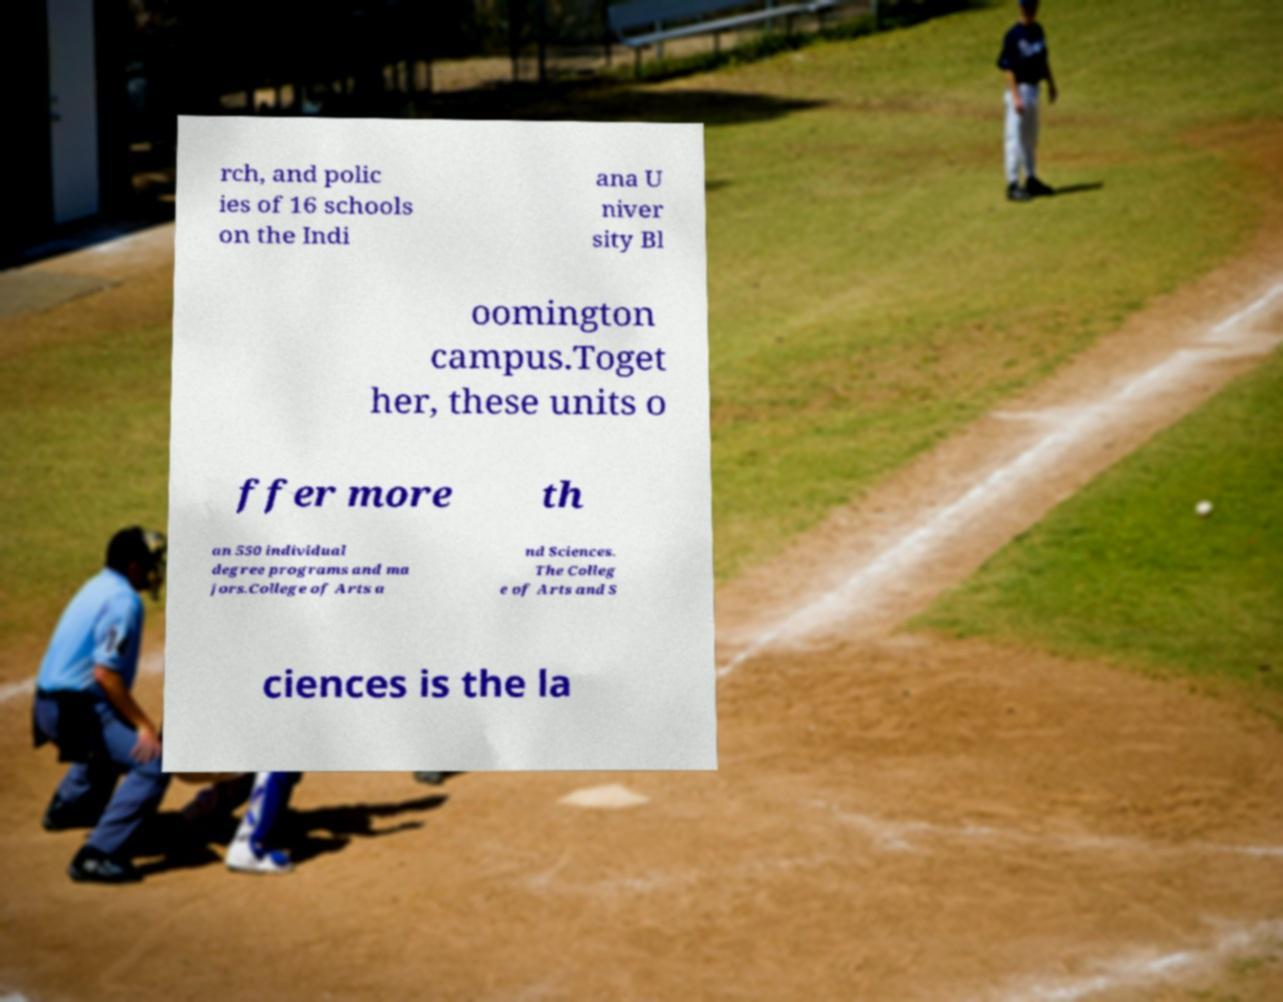Please identify and transcribe the text found in this image. rch, and polic ies of 16 schools on the Indi ana U niver sity Bl oomington campus.Toget her, these units o ffer more th an 550 individual degree programs and ma jors.College of Arts a nd Sciences. The Colleg e of Arts and S ciences is the la 